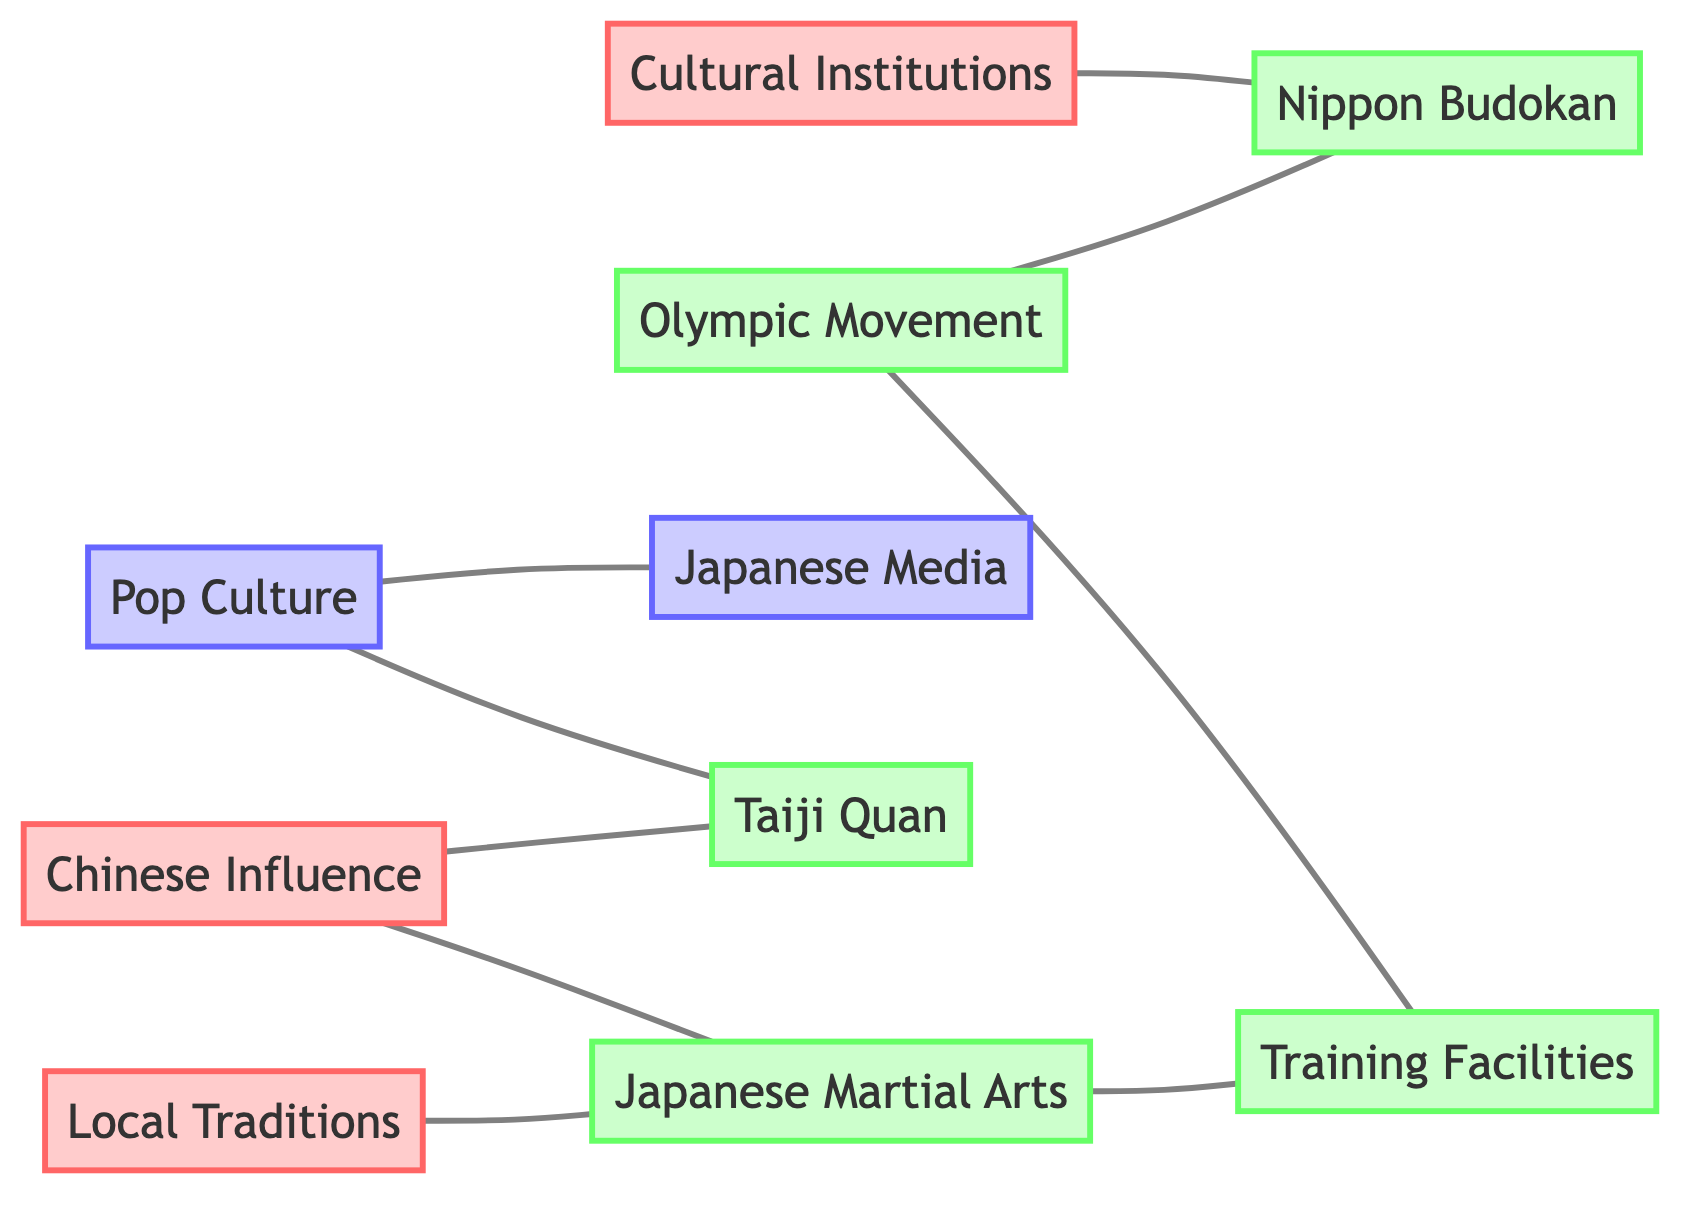What is the total number of nodes in the diagram? Counting the unique entities listed under "nodes," there are 10 distinct nodes represented in the diagram.
Answer: 10 Which two nodes are directly connected to "Olympic Movement"? Examining the edges connected to the "Olympic Movement" node, it connects directly to "Nippon Budokan" and "Training Facilities."
Answer: Nippon Budokan, Training Facilities What type of influence does "Chinese Influence" have on "Taiji Quan"? In the diagram, "Chinese Influence" is directly linked to "Taiji Quan," indicating a direct relationship that showcases the influence.
Answer: Direct How many edges connect to "Japanese Martial Arts"? Looking at the connections for "Japanese Martial Arts," it is linked to two other nodes: "Local Traditions" and "Training Facilities," leading to a total of two edges.
Answer: 2 Which cultural institution is linked to the "Nippon Budokan"? The "Nippon Budokan" node connects with "Cultural Institutions" through an undirected edge. This relationship indicates its association with cultural entities.
Answer: Cultural Institutions What impact does "Pop Culture" have on "Japanese Media"? "Pop Culture" is connected to "Japanese Media," showing its influence within media representation related to cultural practices and martial arts.
Answer: Influence Identify one cultural aspect linked to "Training Facilities". The "Training Facilities" node connects directly to "Japanese Martial Arts" and "Olympic Movement," representing their role in martial arts training and preparation for competitions.
Answer: Japanese Martial Arts Is "Taiji Quan" connected to any form of media in the diagram? "Taiji Quan" is linked to "Pop Culture," indicating a relationship where the martial art is represented or featured in popular media series, films, or performances.
Answer: Yes What does the connection between "Local Traditions" and "Japanese Martial Arts" signify? The connection signifies that "Local Traditions" play a significant role in the development and styles of "Japanese Martial Arts," influencing its practice and teaching.
Answer: Influence 